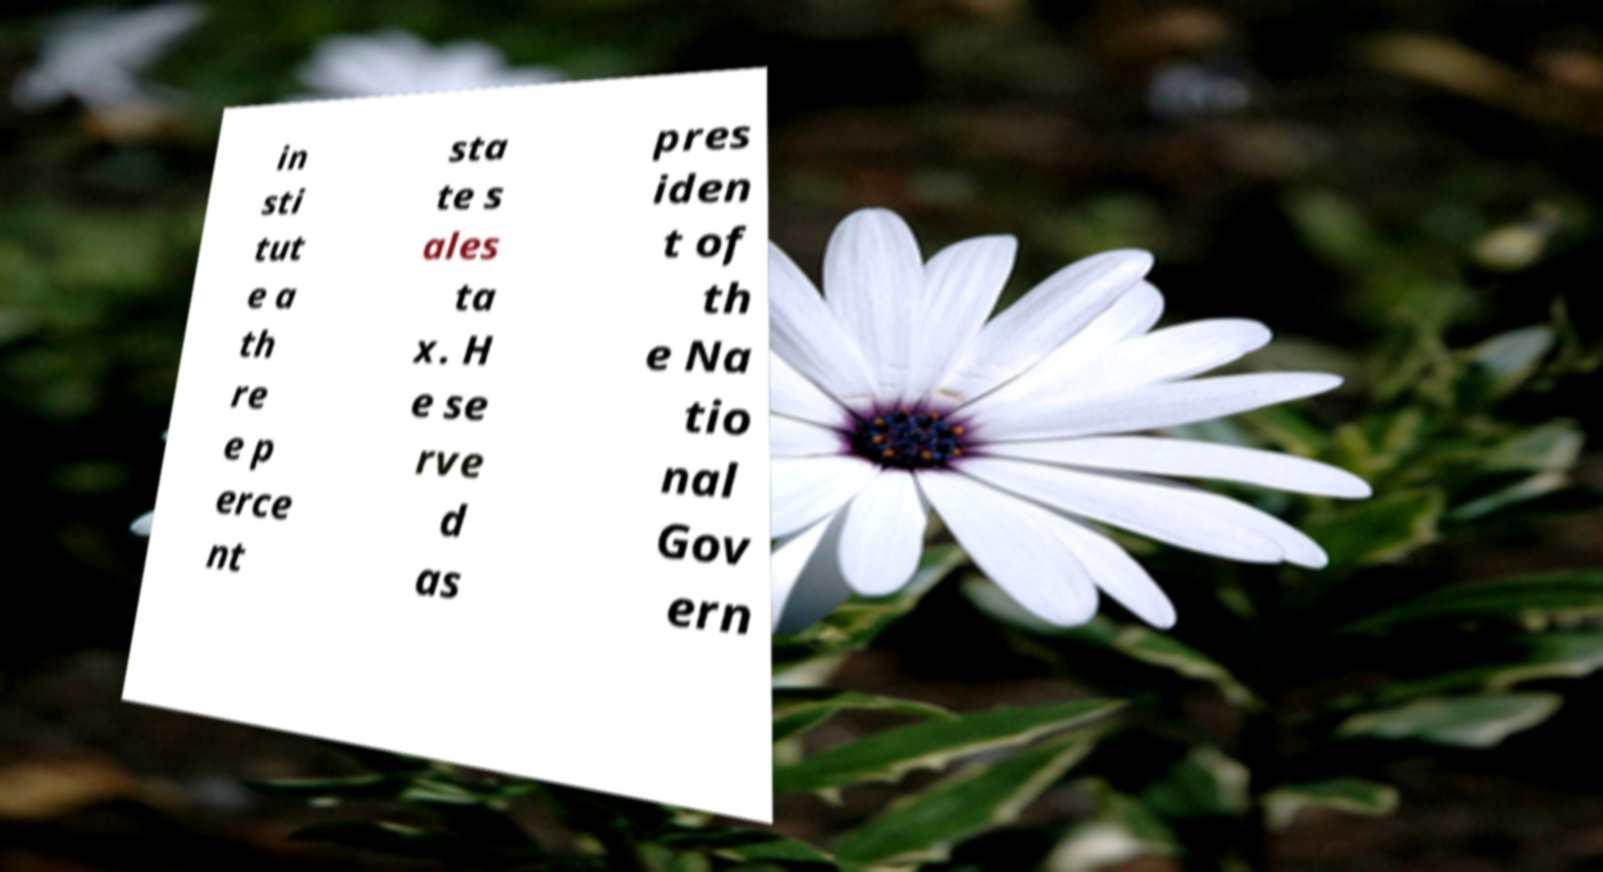I need the written content from this picture converted into text. Can you do that? in sti tut e a th re e p erce nt sta te s ales ta x. H e se rve d as pres iden t of th e Na tio nal Gov ern 